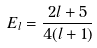Convert formula to latex. <formula><loc_0><loc_0><loc_500><loc_500>E _ { l } = \frac { 2 l + 5 } { 4 ( l + 1 ) }</formula> 